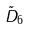Convert formula to latex. <formula><loc_0><loc_0><loc_500><loc_500>\tilde { D } _ { 6 }</formula> 